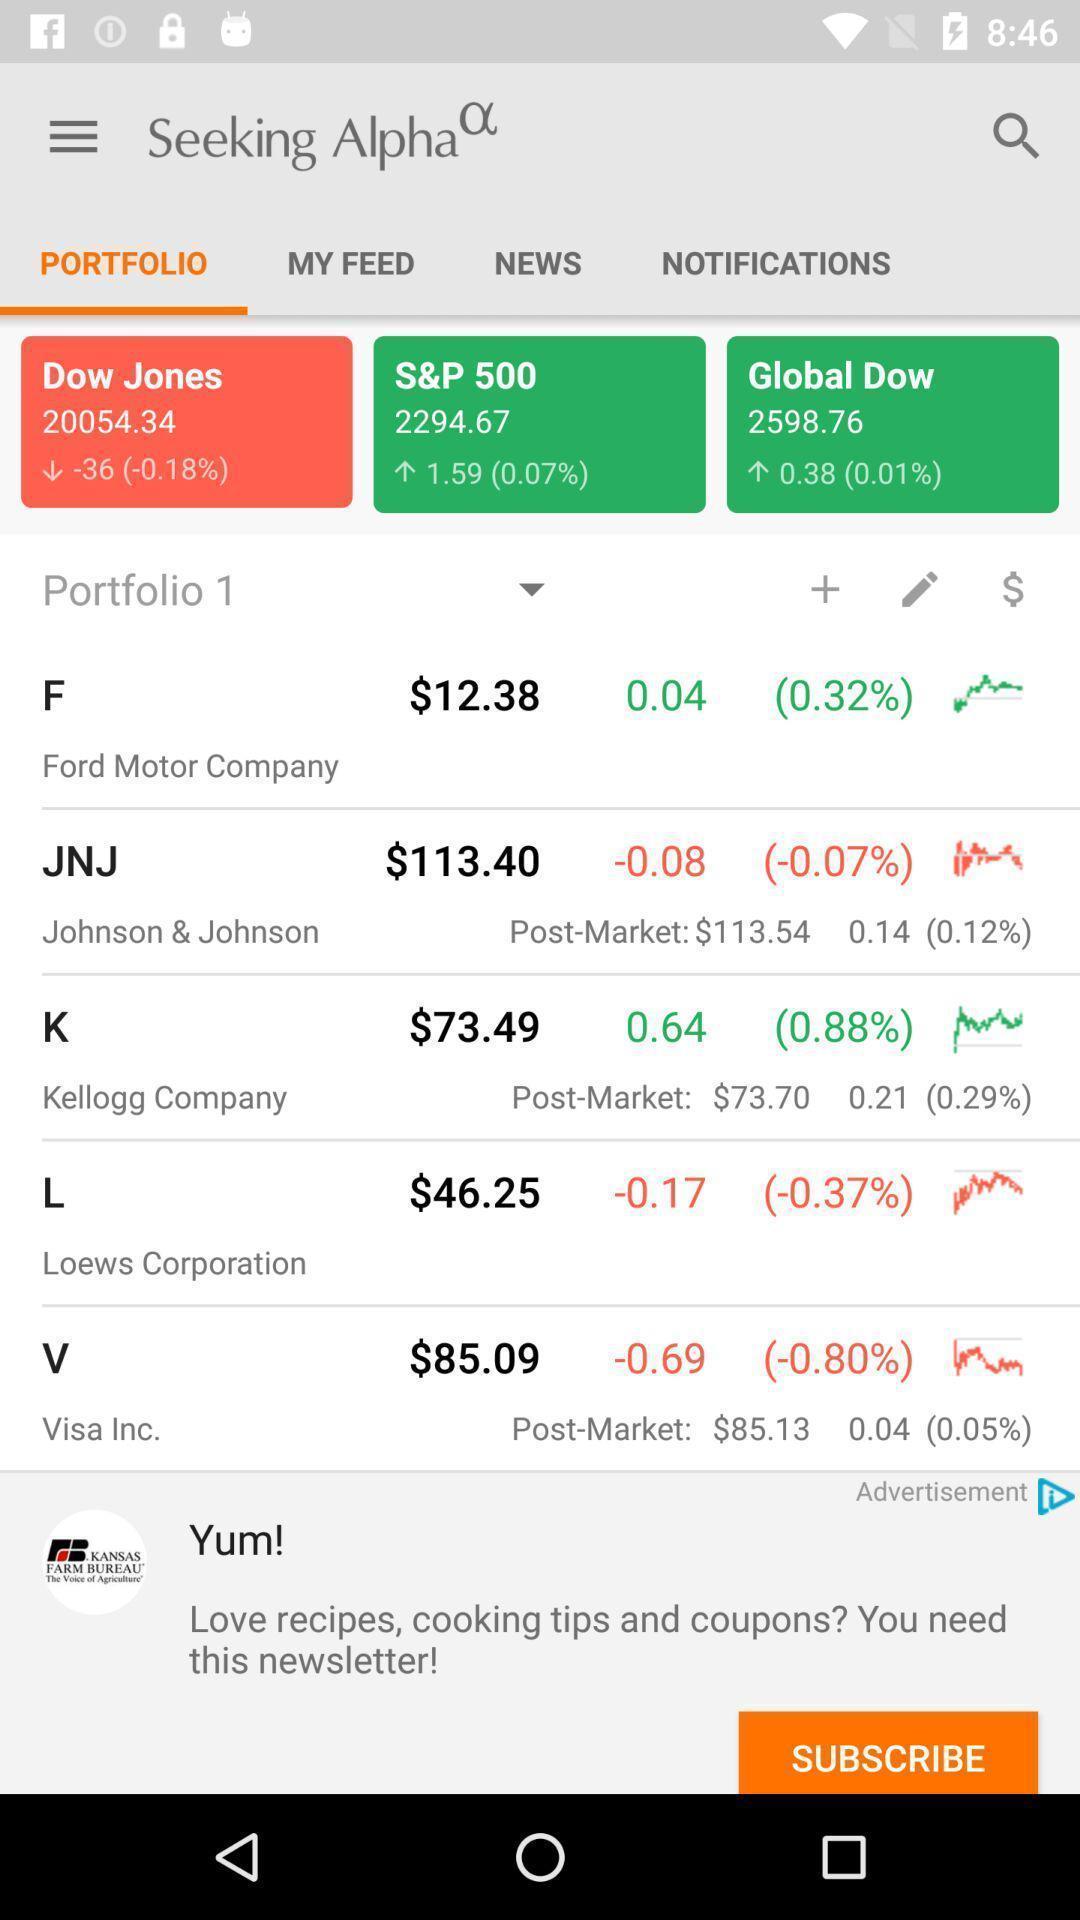Give me a narrative description of this picture. Screen shows a portfolio of market analysis. 